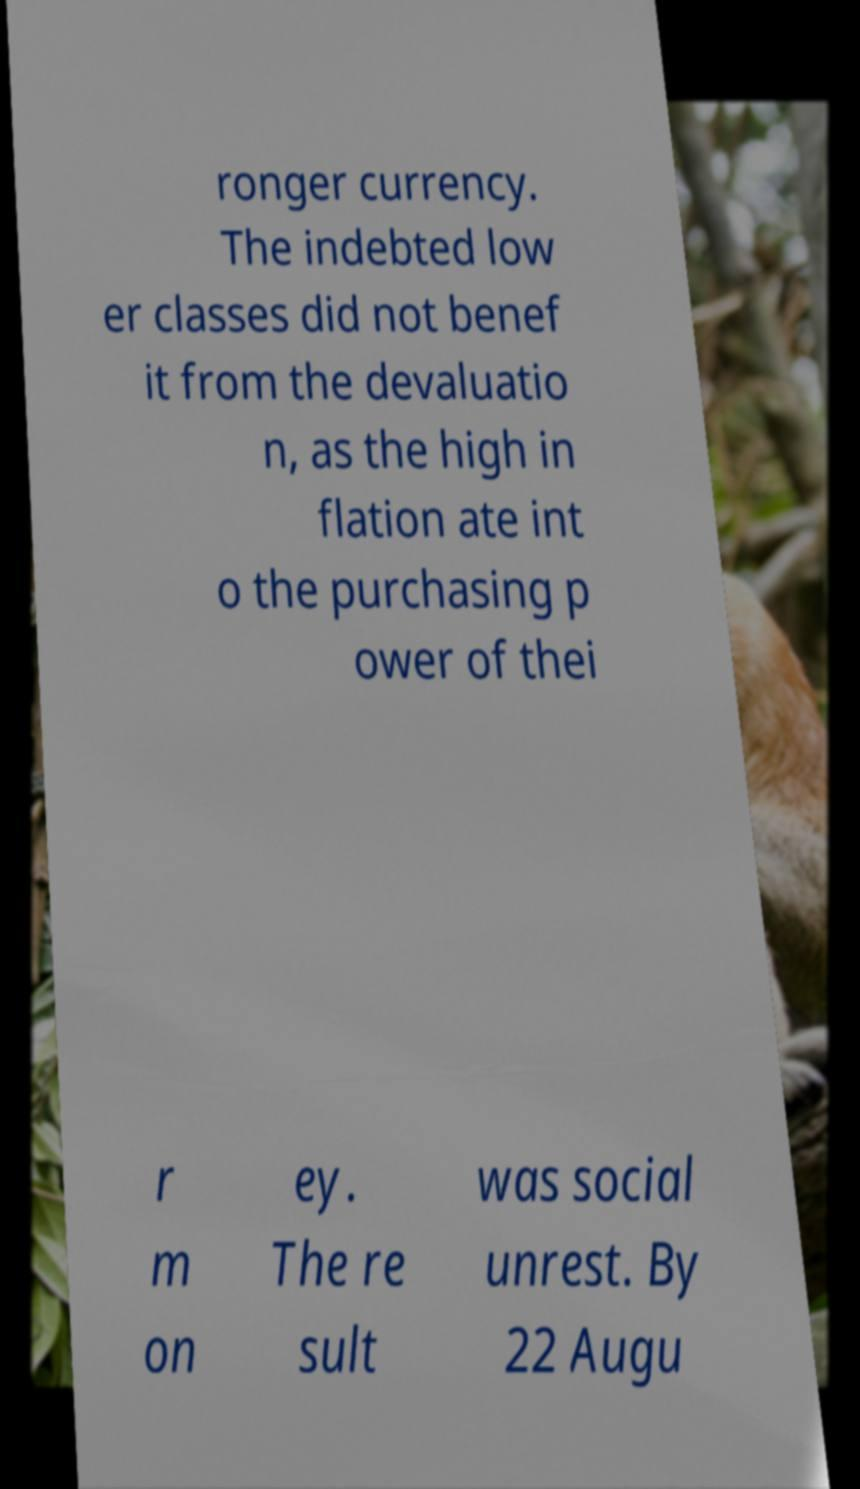There's text embedded in this image that I need extracted. Can you transcribe it verbatim? ronger currency. The indebted low er classes did not benef it from the devaluatio n, as the high in flation ate int o the purchasing p ower of thei r m on ey. The re sult was social unrest. By 22 Augu 